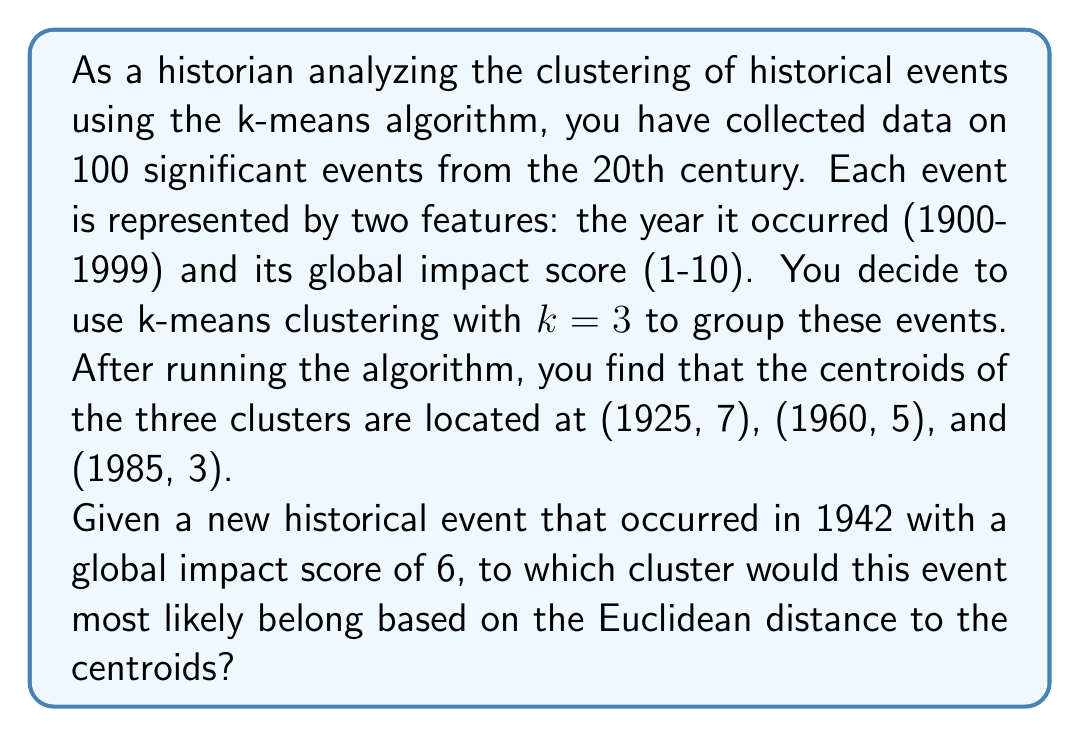Can you answer this question? To solve this problem, we need to calculate the Euclidean distance between the new event (1942, 6) and each of the three cluster centroids. The cluster with the smallest distance will be the one to which the new event is assigned.

The Euclidean distance formula in two dimensions is:

$$d = \sqrt{(x_2 - x_1)^2 + (y_2 - y_1)^2}$$

Where $(x_1, y_1)$ is the new event and $(x_2, y_2)$ is the centroid.

Let's calculate the distance to each centroid:

1. Distance to centroid 1 (1925, 7):
   $$d_1 = \sqrt{(1925 - 1942)^2 + (7 - 6)^2} = \sqrt{289 + 1} = \sqrt{290} \approx 17.03$$

2. Distance to centroid 2 (1960, 5):
   $$d_2 = \sqrt{(1960 - 1942)^2 + (5 - 6)^2} = \sqrt{324 + 1} = \sqrt{325} \approx 18.03$$

3. Distance to centroid 3 (1985, 3):
   $$d_3 = \sqrt{(1985 - 1942)^2 + (3 - 6)^2} = \sqrt{1849 + 9} = \sqrt{1858} \approx 43.10$$

The smallest distance is $d_1 \approx 17.03$, which corresponds to the first centroid (1925, 7).
Answer: The new historical event that occurred in 1942 with a global impact score of 6 would most likely belong to the cluster with centroid (1925, 7). 